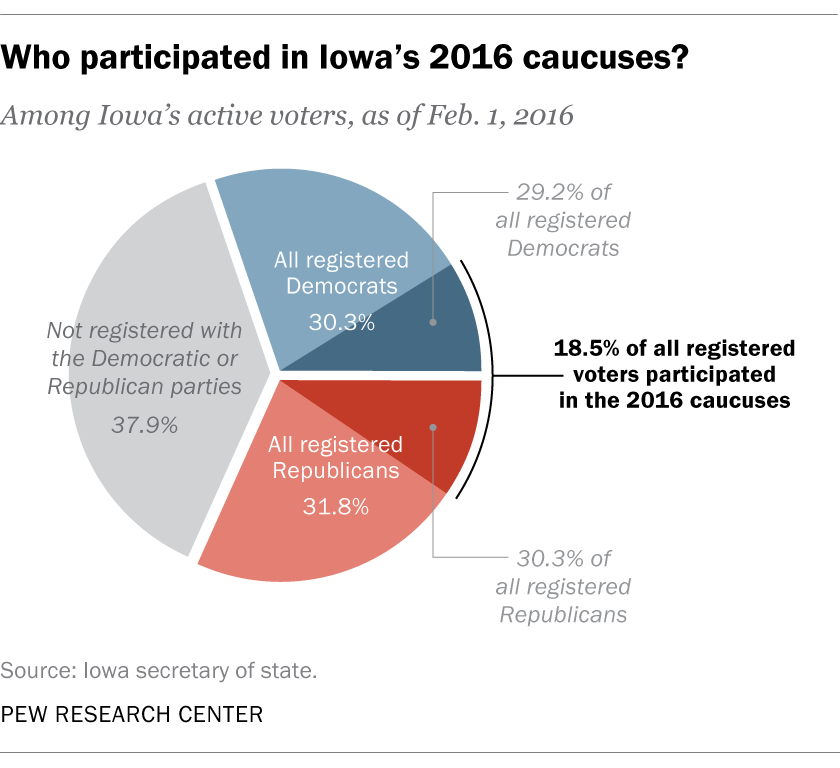Draw attention to some important aspects in this diagram. Approximately 1.5% of total registered Republicans outnumber the total registered Democrats. The total percentage of all registered Democrats is approximately 0.303... 